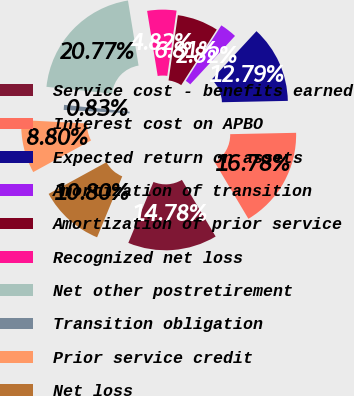Convert chart to OTSL. <chart><loc_0><loc_0><loc_500><loc_500><pie_chart><fcel>Service cost - benefits earned<fcel>Interest cost on APBO<fcel>Expected return on assets<fcel>Amortization of transition<fcel>Amortization of prior service<fcel>Recognized net loss<fcel>Net other postretirement<fcel>Transition obligation<fcel>Prior service credit<fcel>Net loss<nl><fcel>14.78%<fcel>16.78%<fcel>12.79%<fcel>2.82%<fcel>6.81%<fcel>4.82%<fcel>20.77%<fcel>0.83%<fcel>8.8%<fcel>10.8%<nl></chart> 